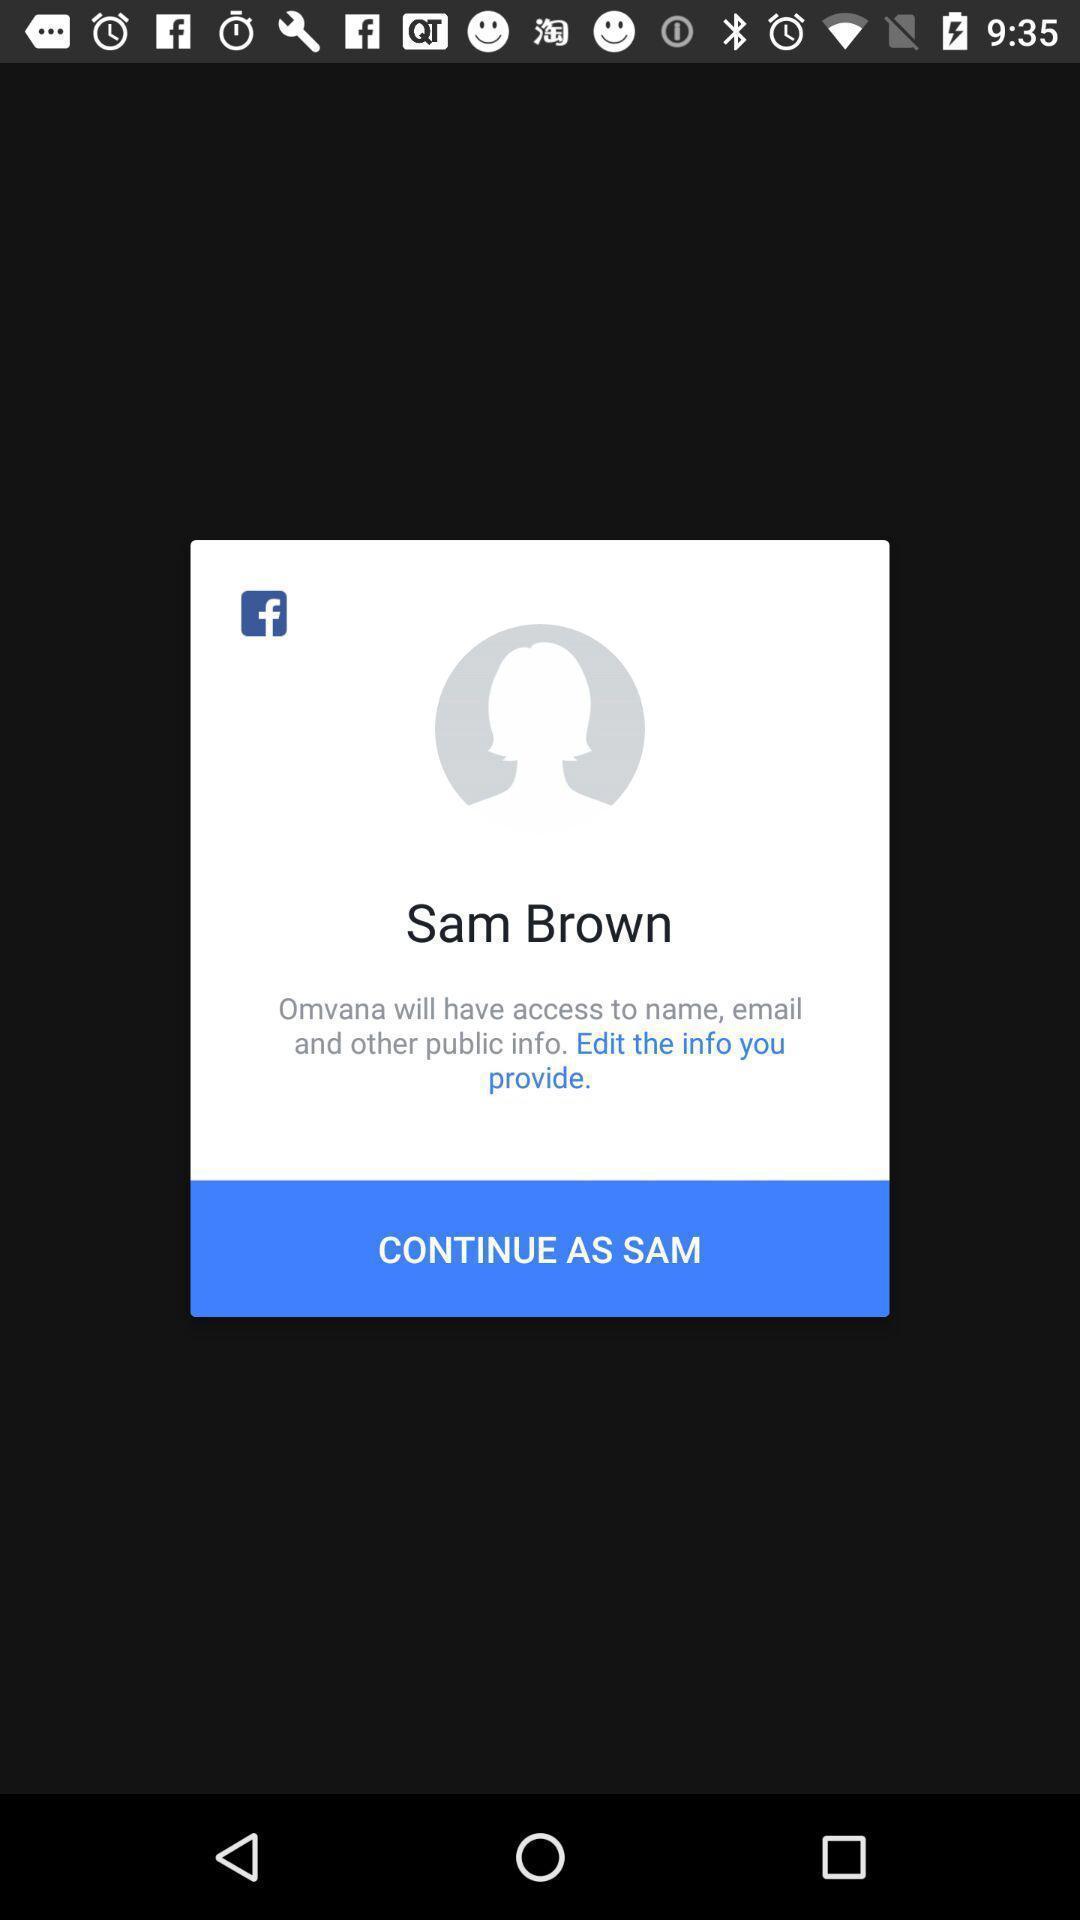Summarize the information in this screenshot. Pop-up showing log-in page of a social app. 